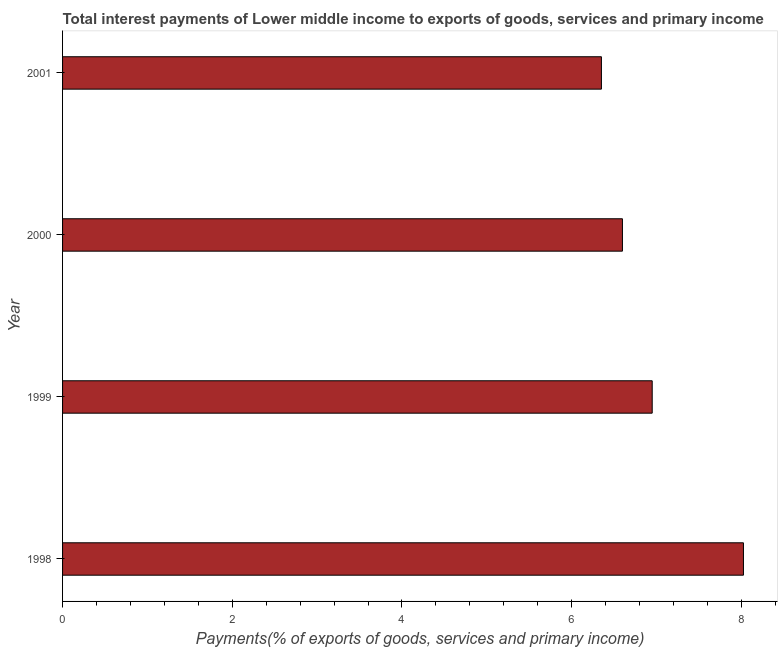What is the title of the graph?
Make the answer very short. Total interest payments of Lower middle income to exports of goods, services and primary income. What is the label or title of the X-axis?
Your response must be concise. Payments(% of exports of goods, services and primary income). What is the label or title of the Y-axis?
Offer a terse response. Year. What is the total interest payments on external debt in 2001?
Make the answer very short. 6.35. Across all years, what is the maximum total interest payments on external debt?
Offer a very short reply. 8.02. Across all years, what is the minimum total interest payments on external debt?
Keep it short and to the point. 6.35. In which year was the total interest payments on external debt maximum?
Give a very brief answer. 1998. In which year was the total interest payments on external debt minimum?
Keep it short and to the point. 2001. What is the sum of the total interest payments on external debt?
Your response must be concise. 27.92. What is the difference between the total interest payments on external debt in 2000 and 2001?
Provide a succinct answer. 0.25. What is the average total interest payments on external debt per year?
Keep it short and to the point. 6.98. What is the median total interest payments on external debt?
Your answer should be compact. 6.77. Do a majority of the years between 1999 and 2001 (inclusive) have total interest payments on external debt greater than 1.6 %?
Your response must be concise. Yes. What is the ratio of the total interest payments on external debt in 1998 to that in 2000?
Provide a short and direct response. 1.22. Is the total interest payments on external debt in 1999 less than that in 2000?
Provide a short and direct response. No. Is the difference between the total interest payments on external debt in 1998 and 2000 greater than the difference between any two years?
Provide a short and direct response. No. What is the difference between the highest and the second highest total interest payments on external debt?
Give a very brief answer. 1.07. Is the sum of the total interest payments on external debt in 1998 and 1999 greater than the maximum total interest payments on external debt across all years?
Offer a very short reply. Yes. What is the difference between the highest and the lowest total interest payments on external debt?
Your response must be concise. 1.67. In how many years, is the total interest payments on external debt greater than the average total interest payments on external debt taken over all years?
Ensure brevity in your answer.  1. Are all the bars in the graph horizontal?
Your answer should be compact. Yes. How many years are there in the graph?
Offer a terse response. 4. What is the Payments(% of exports of goods, services and primary income) in 1998?
Offer a very short reply. 8.02. What is the Payments(% of exports of goods, services and primary income) in 1999?
Make the answer very short. 6.95. What is the Payments(% of exports of goods, services and primary income) of 2000?
Provide a succinct answer. 6.6. What is the Payments(% of exports of goods, services and primary income) in 2001?
Keep it short and to the point. 6.35. What is the difference between the Payments(% of exports of goods, services and primary income) in 1998 and 1999?
Your answer should be compact. 1.08. What is the difference between the Payments(% of exports of goods, services and primary income) in 1998 and 2000?
Your answer should be compact. 1.43. What is the difference between the Payments(% of exports of goods, services and primary income) in 1998 and 2001?
Offer a terse response. 1.67. What is the difference between the Payments(% of exports of goods, services and primary income) in 1999 and 2000?
Your response must be concise. 0.35. What is the difference between the Payments(% of exports of goods, services and primary income) in 1999 and 2001?
Offer a terse response. 0.6. What is the difference between the Payments(% of exports of goods, services and primary income) in 2000 and 2001?
Keep it short and to the point. 0.25. What is the ratio of the Payments(% of exports of goods, services and primary income) in 1998 to that in 1999?
Your answer should be compact. 1.16. What is the ratio of the Payments(% of exports of goods, services and primary income) in 1998 to that in 2000?
Your answer should be compact. 1.22. What is the ratio of the Payments(% of exports of goods, services and primary income) in 1998 to that in 2001?
Provide a short and direct response. 1.26. What is the ratio of the Payments(% of exports of goods, services and primary income) in 1999 to that in 2000?
Ensure brevity in your answer.  1.05. What is the ratio of the Payments(% of exports of goods, services and primary income) in 1999 to that in 2001?
Ensure brevity in your answer.  1.09. What is the ratio of the Payments(% of exports of goods, services and primary income) in 2000 to that in 2001?
Keep it short and to the point. 1.04. 